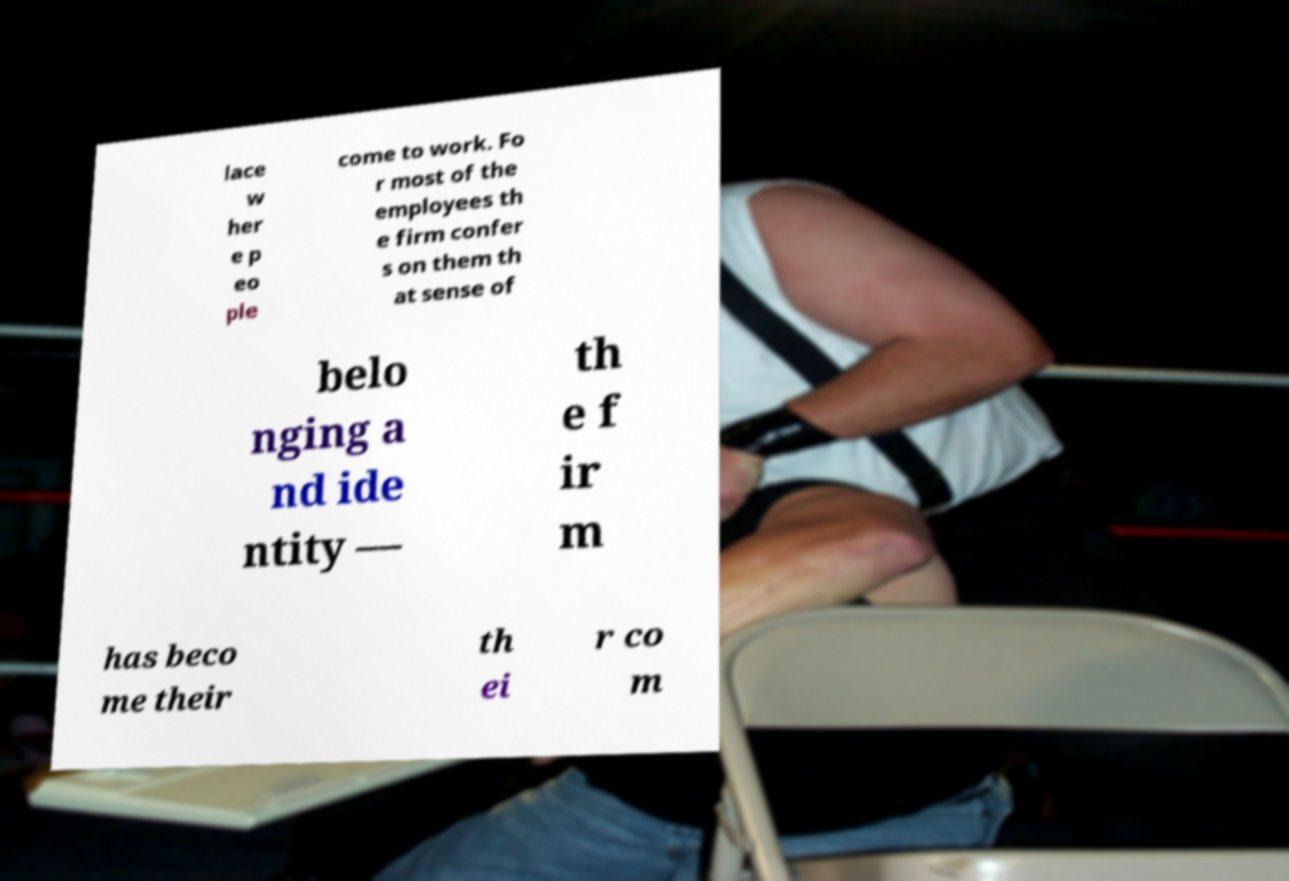I need the written content from this picture converted into text. Can you do that? lace w her e p eo ple come to work. Fo r most of the employees th e firm confer s on them th at sense of belo nging a nd ide ntity –– th e f ir m has beco me their th ei r co m 